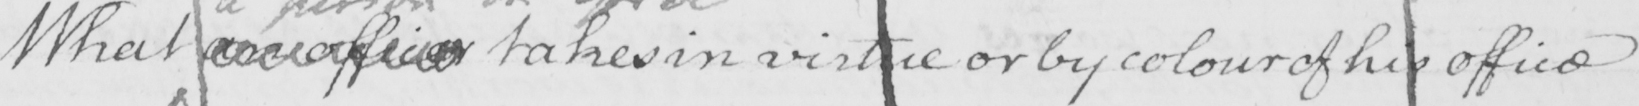Can you tell me what this handwritten text says? What an officer takes in virtue or by colour of his office 